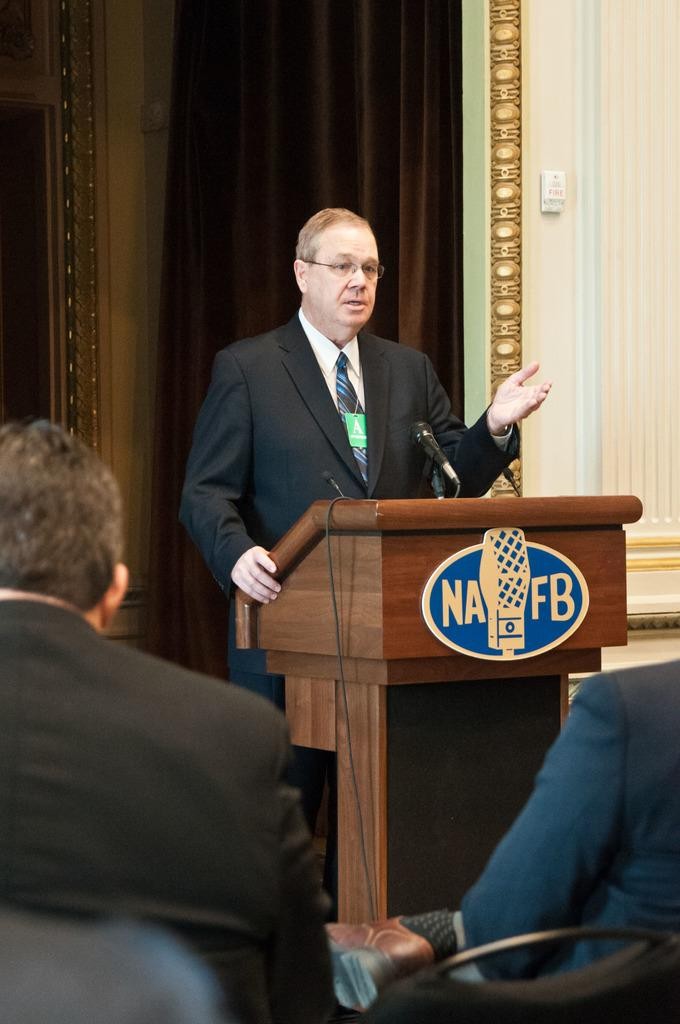What is the man in the image doing? The man is standing in front of a microphone. What object is present near the man? There is a podium in the image. How many people are sitting in the image? Two persons are sitting on chairs. What can be seen in the background of the image? There is a wall and a curtain in the background of the image. What type of machine is being used by the man in the image? There is no machine present in the image; the man is standing in front of a microphone. What type of joke is being told by the man in the image? There is no joke being told in the image; the man is standing in front of a microphone, which suggests he might be speaking or performing. 